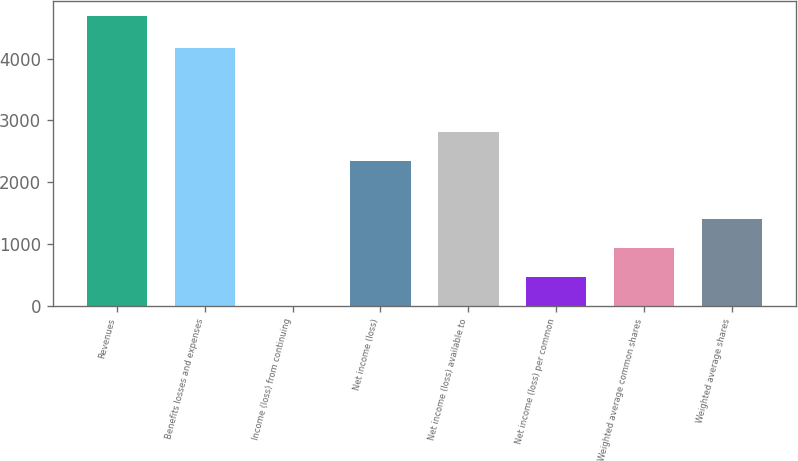Convert chart. <chart><loc_0><loc_0><loc_500><loc_500><bar_chart><fcel>Revenues<fcel>Benefits losses and expenses<fcel>Income (loss) from continuing<fcel>Net income (loss)<fcel>Net income (loss) available to<fcel>Net income (loss) per common<fcel>Weighted average common shares<fcel>Weighted average shares<nl><fcel>4691<fcel>4172<fcel>1.2<fcel>2346.1<fcel>2815.08<fcel>470.18<fcel>939.16<fcel>1408.14<nl></chart> 